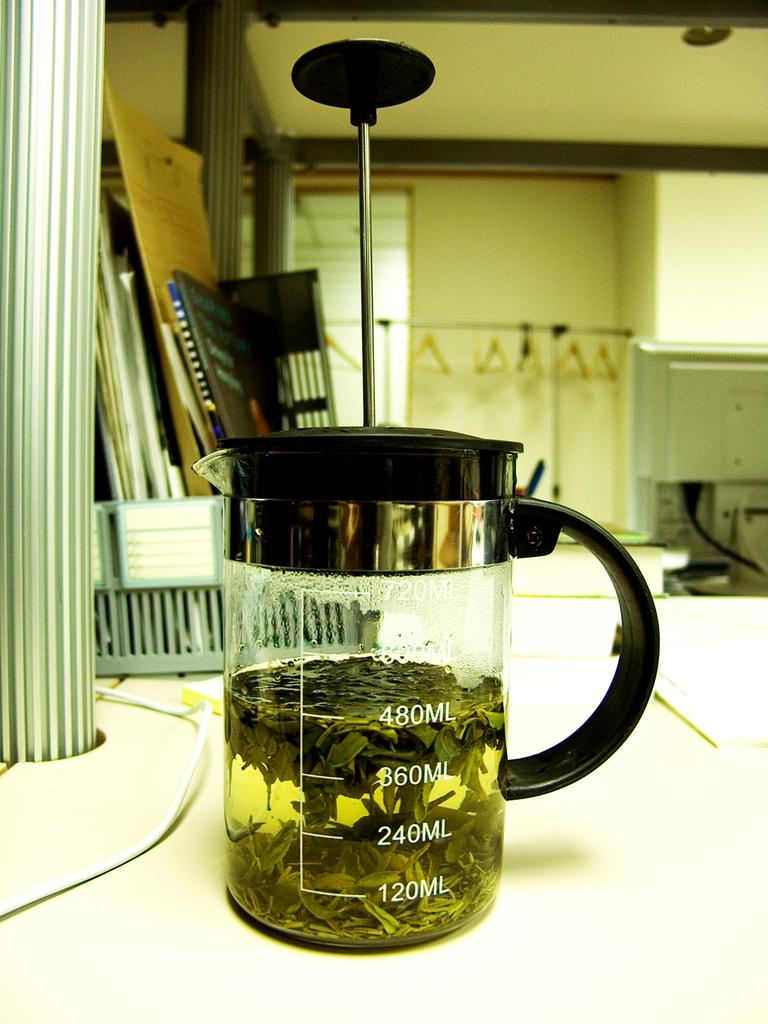Provide a one-sentence caption for the provided image. The jar can hold a maximum of 720 milliliters of fluid. 